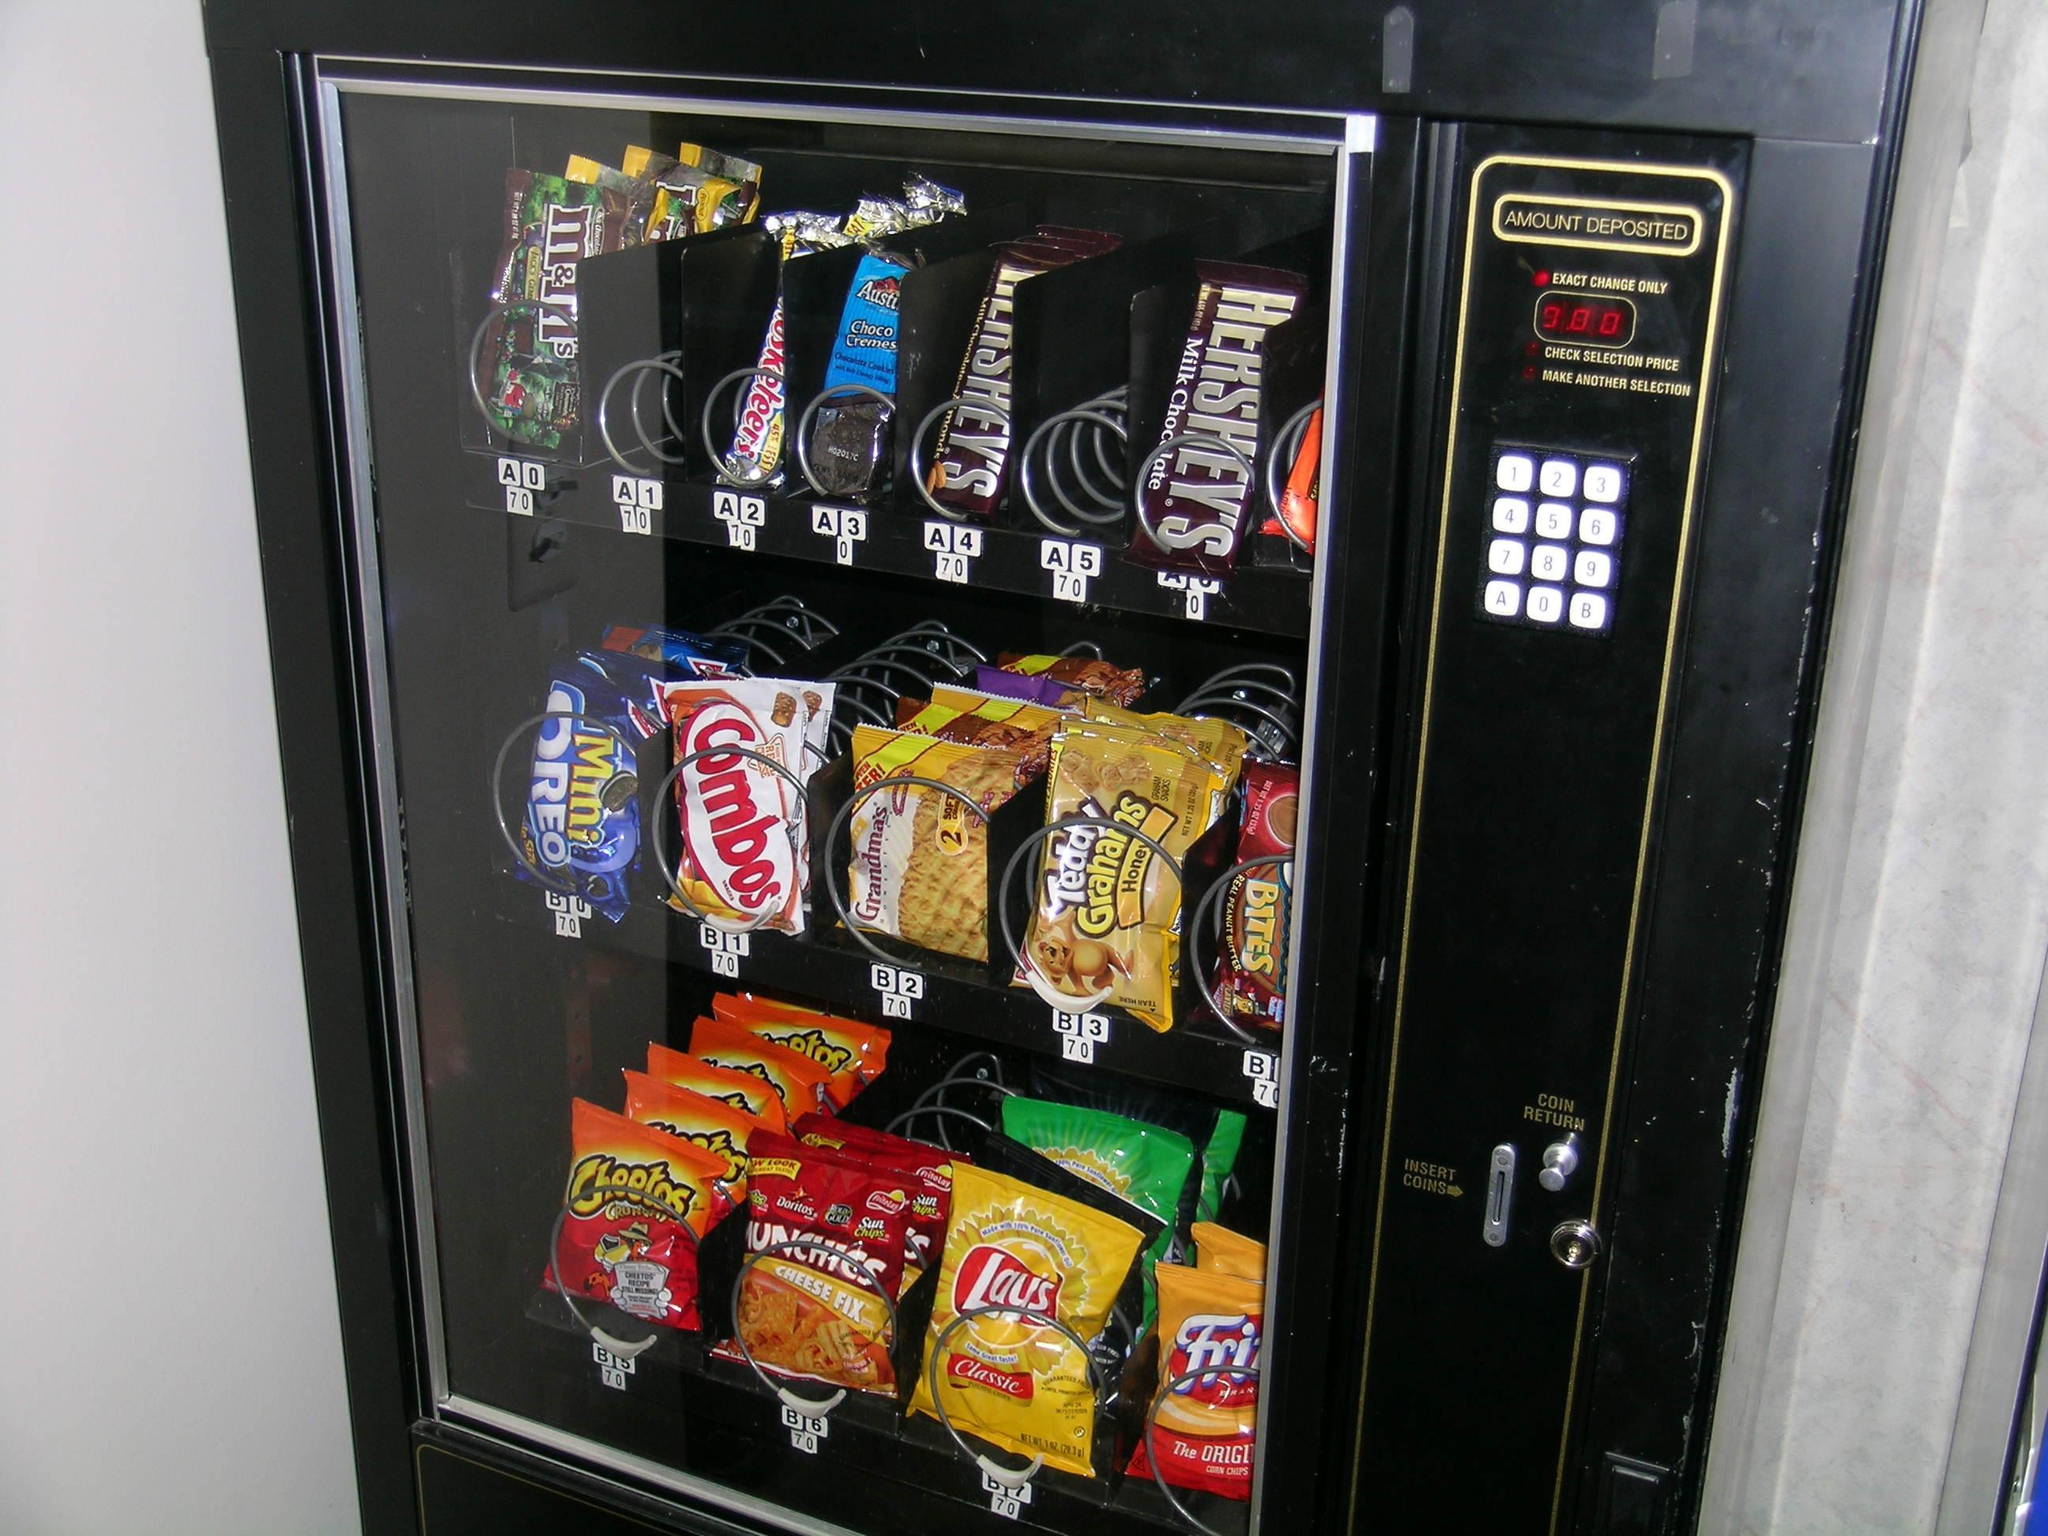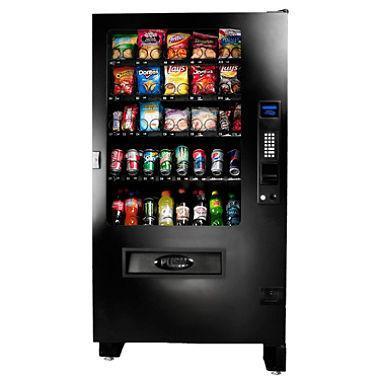The first image is the image on the left, the second image is the image on the right. For the images displayed, is the sentence "There are at least three vending machines in the image on the right." factually correct? Answer yes or no. No. 